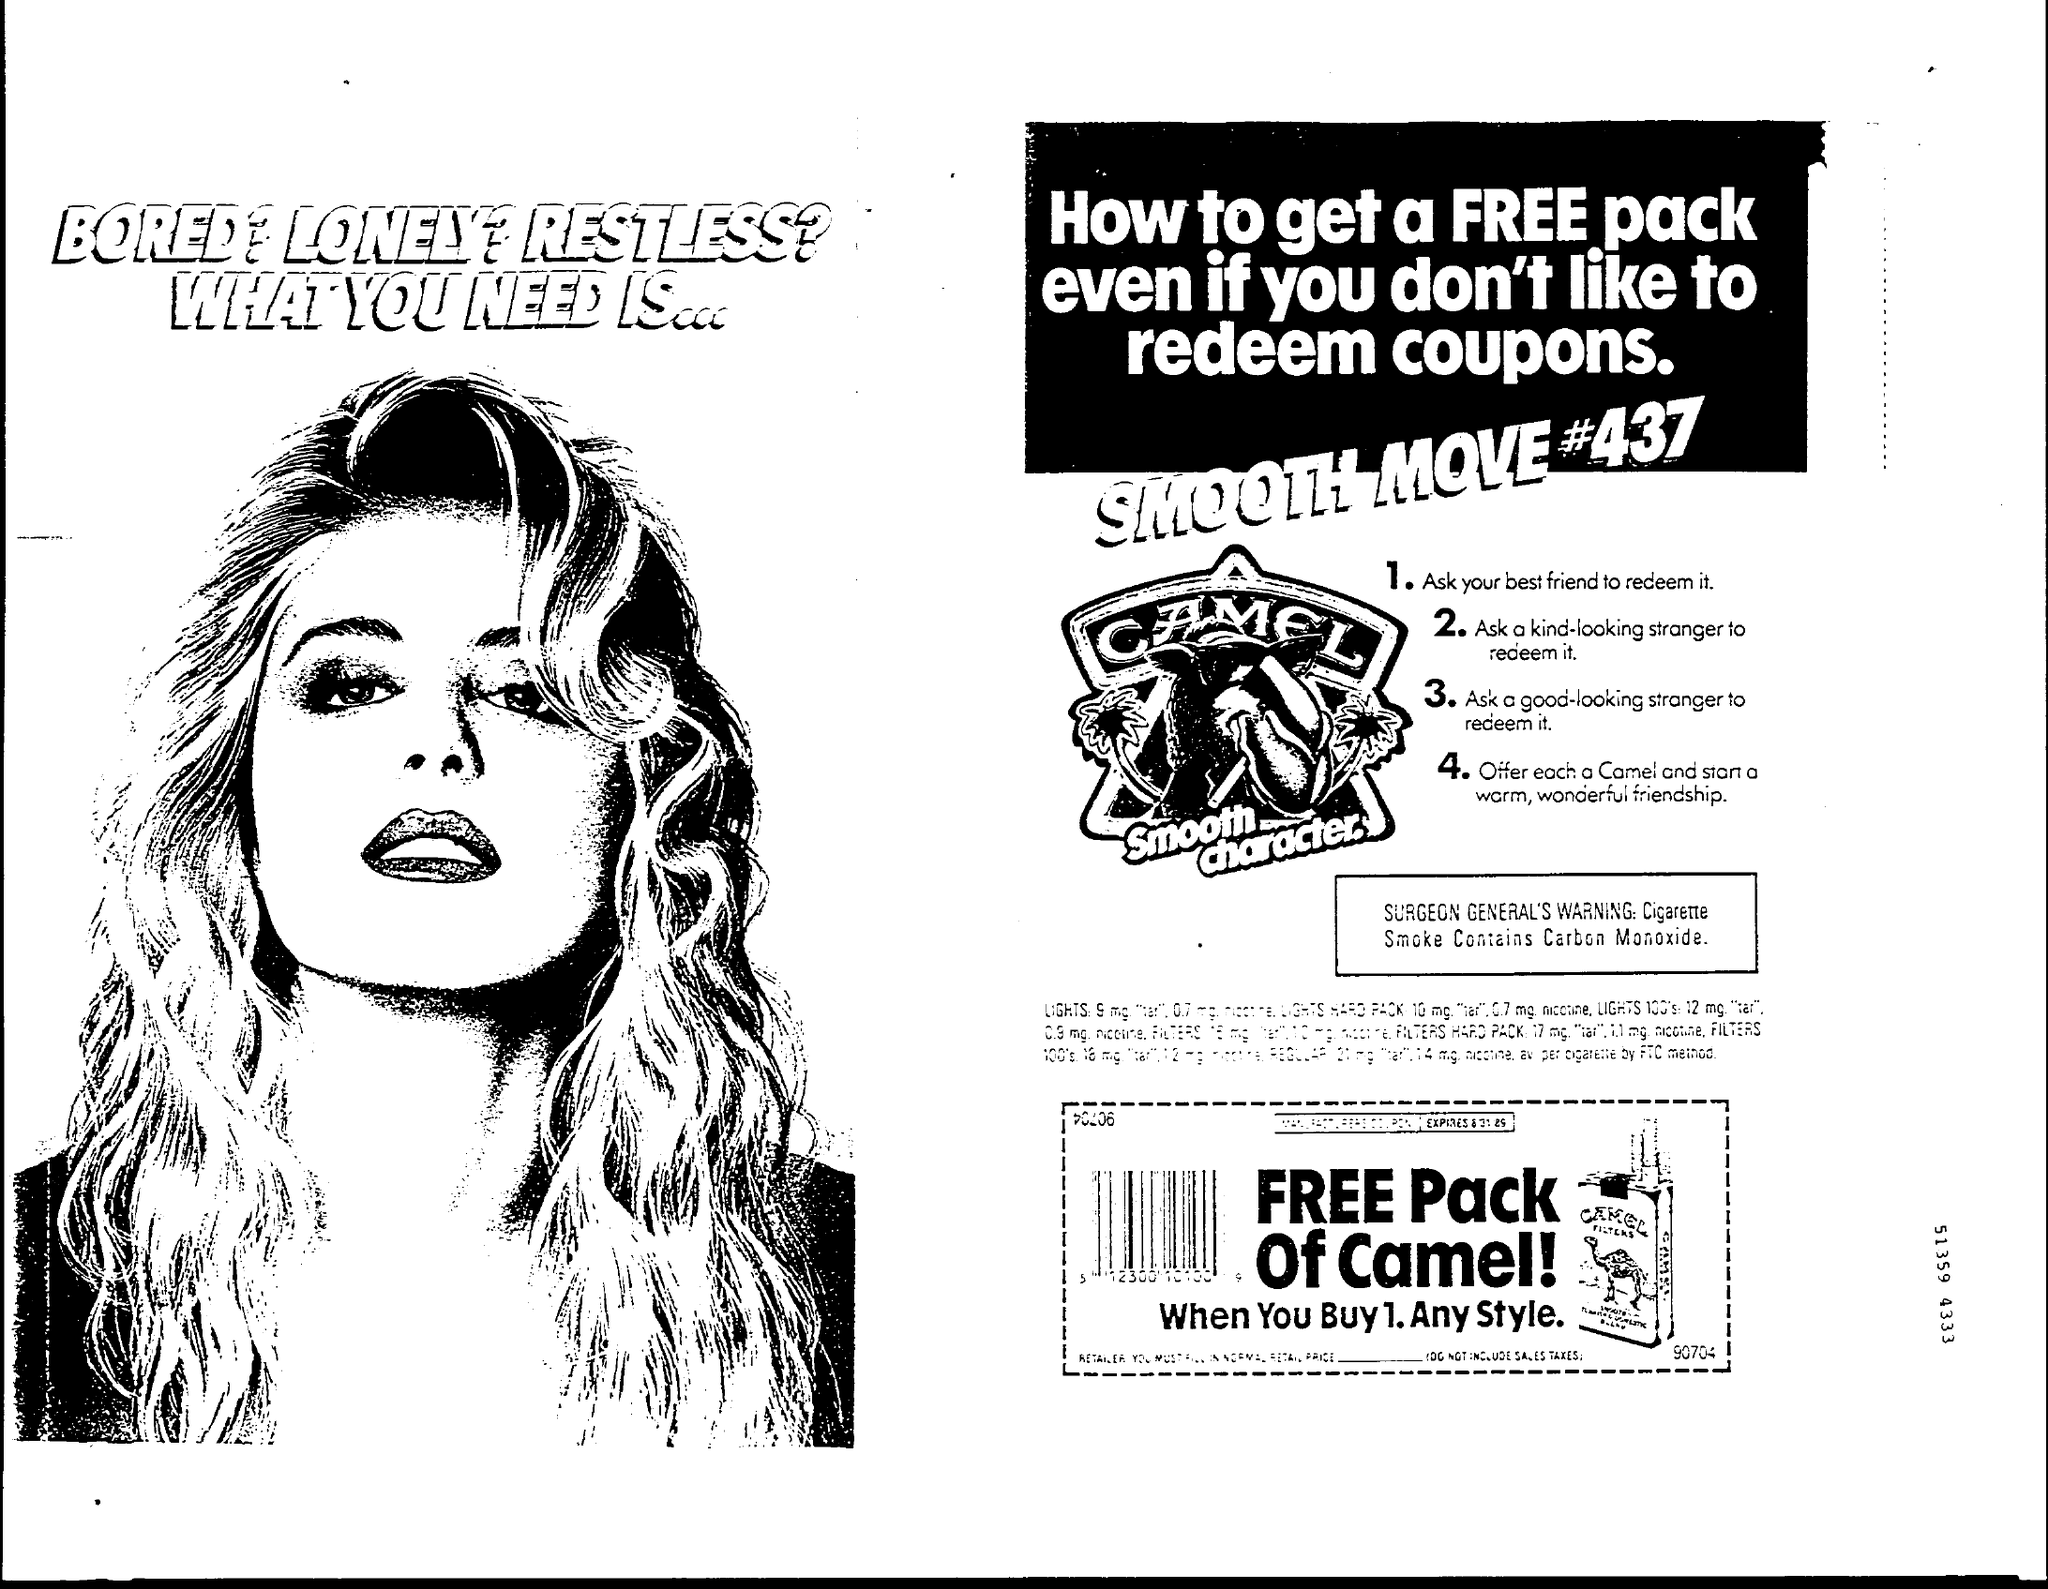What is the SURGEON GENERAL'S warning?
Offer a terse response. Cigarette Smoke Contains Carbon Monoxide. Which brand is mentioned?
Offer a very short reply. CAMEL. 